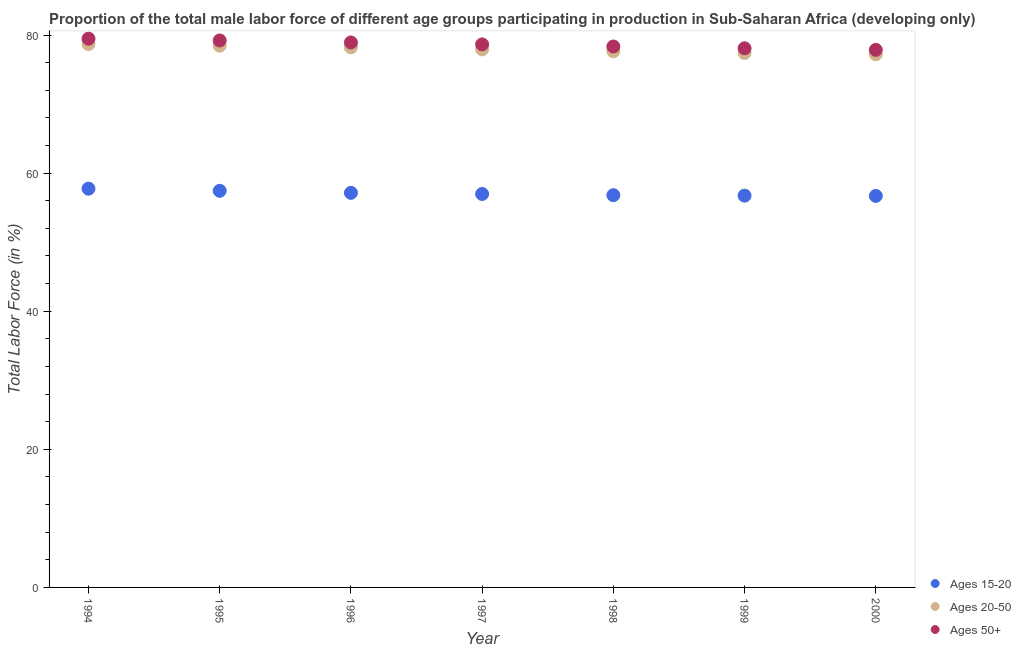How many different coloured dotlines are there?
Provide a short and direct response. 3. What is the percentage of male labor force within the age group 20-50 in 2000?
Ensure brevity in your answer.  77.21. Across all years, what is the maximum percentage of male labor force within the age group 20-50?
Ensure brevity in your answer.  78.69. Across all years, what is the minimum percentage of male labor force above age 50?
Provide a short and direct response. 77.85. In which year was the percentage of male labor force above age 50 minimum?
Provide a short and direct response. 2000. What is the total percentage of male labor force within the age group 15-20 in the graph?
Provide a short and direct response. 399.57. What is the difference between the percentage of male labor force above age 50 in 1995 and that in 1996?
Offer a very short reply. 0.29. What is the difference between the percentage of male labor force within the age group 15-20 in 1997 and the percentage of male labor force within the age group 20-50 in 1996?
Keep it short and to the point. -21.23. What is the average percentage of male labor force within the age group 15-20 per year?
Provide a succinct answer. 57.08. In the year 1995, what is the difference between the percentage of male labor force above age 50 and percentage of male labor force within the age group 20-50?
Provide a short and direct response. 0.76. What is the ratio of the percentage of male labor force above age 50 in 1997 to that in 2000?
Offer a very short reply. 1.01. Is the difference between the percentage of male labor force within the age group 20-50 in 1998 and 1999 greater than the difference between the percentage of male labor force above age 50 in 1998 and 1999?
Provide a succinct answer. No. What is the difference between the highest and the second highest percentage of male labor force above age 50?
Ensure brevity in your answer.  0.26. What is the difference between the highest and the lowest percentage of male labor force above age 50?
Your answer should be compact. 1.62. Is the percentage of male labor force above age 50 strictly greater than the percentage of male labor force within the age group 15-20 over the years?
Provide a succinct answer. Yes. What is the difference between two consecutive major ticks on the Y-axis?
Your answer should be compact. 20. Does the graph contain any zero values?
Provide a succinct answer. No. Does the graph contain grids?
Ensure brevity in your answer.  No. Where does the legend appear in the graph?
Provide a short and direct response. Bottom right. How many legend labels are there?
Make the answer very short. 3. What is the title of the graph?
Ensure brevity in your answer.  Proportion of the total male labor force of different age groups participating in production in Sub-Saharan Africa (developing only). What is the label or title of the X-axis?
Your answer should be very brief. Year. What is the Total Labor Force (in %) of Ages 15-20 in 1994?
Keep it short and to the point. 57.75. What is the Total Labor Force (in %) of Ages 20-50 in 1994?
Give a very brief answer. 78.69. What is the Total Labor Force (in %) in Ages 50+ in 1994?
Provide a succinct answer. 79.47. What is the Total Labor Force (in %) in Ages 15-20 in 1995?
Offer a very short reply. 57.44. What is the Total Labor Force (in %) in Ages 20-50 in 1995?
Make the answer very short. 78.45. What is the Total Labor Force (in %) of Ages 50+ in 1995?
Give a very brief answer. 79.22. What is the Total Labor Force (in %) in Ages 15-20 in 1996?
Your response must be concise. 57.15. What is the Total Labor Force (in %) in Ages 20-50 in 1996?
Offer a terse response. 78.21. What is the Total Labor Force (in %) of Ages 50+ in 1996?
Provide a short and direct response. 78.93. What is the Total Labor Force (in %) in Ages 15-20 in 1997?
Keep it short and to the point. 56.98. What is the Total Labor Force (in %) in Ages 20-50 in 1997?
Give a very brief answer. 77.92. What is the Total Labor Force (in %) of Ages 50+ in 1997?
Give a very brief answer. 78.65. What is the Total Labor Force (in %) of Ages 15-20 in 1998?
Provide a succinct answer. 56.81. What is the Total Labor Force (in %) in Ages 20-50 in 1998?
Your response must be concise. 77.65. What is the Total Labor Force (in %) of Ages 50+ in 1998?
Keep it short and to the point. 78.34. What is the Total Labor Force (in %) in Ages 15-20 in 1999?
Your response must be concise. 56.74. What is the Total Labor Force (in %) of Ages 20-50 in 1999?
Your answer should be very brief. 77.4. What is the Total Labor Force (in %) of Ages 50+ in 1999?
Offer a very short reply. 78.08. What is the Total Labor Force (in %) in Ages 15-20 in 2000?
Keep it short and to the point. 56.7. What is the Total Labor Force (in %) in Ages 20-50 in 2000?
Keep it short and to the point. 77.21. What is the Total Labor Force (in %) in Ages 50+ in 2000?
Ensure brevity in your answer.  77.85. Across all years, what is the maximum Total Labor Force (in %) in Ages 15-20?
Offer a terse response. 57.75. Across all years, what is the maximum Total Labor Force (in %) in Ages 20-50?
Ensure brevity in your answer.  78.69. Across all years, what is the maximum Total Labor Force (in %) of Ages 50+?
Your answer should be very brief. 79.47. Across all years, what is the minimum Total Labor Force (in %) in Ages 15-20?
Offer a very short reply. 56.7. Across all years, what is the minimum Total Labor Force (in %) in Ages 20-50?
Your answer should be very brief. 77.21. Across all years, what is the minimum Total Labor Force (in %) in Ages 50+?
Make the answer very short. 77.85. What is the total Total Labor Force (in %) of Ages 15-20 in the graph?
Give a very brief answer. 399.57. What is the total Total Labor Force (in %) of Ages 20-50 in the graph?
Offer a terse response. 545.55. What is the total Total Labor Force (in %) of Ages 50+ in the graph?
Provide a short and direct response. 550.54. What is the difference between the Total Labor Force (in %) in Ages 15-20 in 1994 and that in 1995?
Give a very brief answer. 0.31. What is the difference between the Total Labor Force (in %) of Ages 20-50 in 1994 and that in 1995?
Offer a terse response. 0.24. What is the difference between the Total Labor Force (in %) in Ages 50+ in 1994 and that in 1995?
Your answer should be very brief. 0.26. What is the difference between the Total Labor Force (in %) of Ages 15-20 in 1994 and that in 1996?
Offer a terse response. 0.6. What is the difference between the Total Labor Force (in %) of Ages 20-50 in 1994 and that in 1996?
Offer a very short reply. 0.48. What is the difference between the Total Labor Force (in %) of Ages 50+ in 1994 and that in 1996?
Provide a short and direct response. 0.54. What is the difference between the Total Labor Force (in %) in Ages 15-20 in 1994 and that in 1997?
Your answer should be very brief. 0.77. What is the difference between the Total Labor Force (in %) of Ages 20-50 in 1994 and that in 1997?
Offer a very short reply. 0.77. What is the difference between the Total Labor Force (in %) in Ages 50+ in 1994 and that in 1997?
Make the answer very short. 0.83. What is the difference between the Total Labor Force (in %) in Ages 15-20 in 1994 and that in 1998?
Your response must be concise. 0.94. What is the difference between the Total Labor Force (in %) in Ages 20-50 in 1994 and that in 1998?
Provide a short and direct response. 1.05. What is the difference between the Total Labor Force (in %) in Ages 50+ in 1994 and that in 1998?
Offer a terse response. 1.13. What is the difference between the Total Labor Force (in %) in Ages 15-20 in 1994 and that in 1999?
Offer a terse response. 1.01. What is the difference between the Total Labor Force (in %) in Ages 20-50 in 1994 and that in 1999?
Offer a very short reply. 1.29. What is the difference between the Total Labor Force (in %) of Ages 50+ in 1994 and that in 1999?
Give a very brief answer. 1.39. What is the difference between the Total Labor Force (in %) of Ages 15-20 in 1994 and that in 2000?
Keep it short and to the point. 1.05. What is the difference between the Total Labor Force (in %) in Ages 20-50 in 1994 and that in 2000?
Give a very brief answer. 1.48. What is the difference between the Total Labor Force (in %) in Ages 50+ in 1994 and that in 2000?
Give a very brief answer. 1.62. What is the difference between the Total Labor Force (in %) of Ages 15-20 in 1995 and that in 1996?
Keep it short and to the point. 0.29. What is the difference between the Total Labor Force (in %) in Ages 20-50 in 1995 and that in 1996?
Your answer should be very brief. 0.24. What is the difference between the Total Labor Force (in %) of Ages 50+ in 1995 and that in 1996?
Offer a very short reply. 0.29. What is the difference between the Total Labor Force (in %) in Ages 15-20 in 1995 and that in 1997?
Offer a terse response. 0.46. What is the difference between the Total Labor Force (in %) of Ages 20-50 in 1995 and that in 1997?
Your answer should be compact. 0.53. What is the difference between the Total Labor Force (in %) of Ages 50+ in 1995 and that in 1997?
Ensure brevity in your answer.  0.57. What is the difference between the Total Labor Force (in %) of Ages 15-20 in 1995 and that in 1998?
Provide a succinct answer. 0.63. What is the difference between the Total Labor Force (in %) of Ages 20-50 in 1995 and that in 1998?
Offer a very short reply. 0.81. What is the difference between the Total Labor Force (in %) of Ages 50+ in 1995 and that in 1998?
Offer a terse response. 0.88. What is the difference between the Total Labor Force (in %) in Ages 15-20 in 1995 and that in 1999?
Offer a very short reply. 0.7. What is the difference between the Total Labor Force (in %) of Ages 20-50 in 1995 and that in 1999?
Your response must be concise. 1.05. What is the difference between the Total Labor Force (in %) in Ages 50+ in 1995 and that in 1999?
Offer a terse response. 1.14. What is the difference between the Total Labor Force (in %) in Ages 15-20 in 1995 and that in 2000?
Offer a terse response. 0.74. What is the difference between the Total Labor Force (in %) of Ages 20-50 in 1995 and that in 2000?
Your response must be concise. 1.24. What is the difference between the Total Labor Force (in %) in Ages 50+ in 1995 and that in 2000?
Your answer should be very brief. 1.36. What is the difference between the Total Labor Force (in %) in Ages 15-20 in 1996 and that in 1997?
Your response must be concise. 0.17. What is the difference between the Total Labor Force (in %) in Ages 20-50 in 1996 and that in 1997?
Offer a terse response. 0.29. What is the difference between the Total Labor Force (in %) of Ages 50+ in 1996 and that in 1997?
Your answer should be very brief. 0.28. What is the difference between the Total Labor Force (in %) in Ages 15-20 in 1996 and that in 1998?
Give a very brief answer. 0.34. What is the difference between the Total Labor Force (in %) in Ages 20-50 in 1996 and that in 1998?
Make the answer very short. 0.57. What is the difference between the Total Labor Force (in %) in Ages 50+ in 1996 and that in 1998?
Provide a succinct answer. 0.59. What is the difference between the Total Labor Force (in %) of Ages 15-20 in 1996 and that in 1999?
Offer a terse response. 0.41. What is the difference between the Total Labor Force (in %) of Ages 20-50 in 1996 and that in 1999?
Give a very brief answer. 0.81. What is the difference between the Total Labor Force (in %) in Ages 50+ in 1996 and that in 1999?
Keep it short and to the point. 0.85. What is the difference between the Total Labor Force (in %) of Ages 15-20 in 1996 and that in 2000?
Your answer should be compact. 0.44. What is the difference between the Total Labor Force (in %) of Ages 20-50 in 1996 and that in 2000?
Your response must be concise. 1. What is the difference between the Total Labor Force (in %) in Ages 50+ in 1996 and that in 2000?
Offer a terse response. 1.07. What is the difference between the Total Labor Force (in %) of Ages 15-20 in 1997 and that in 1998?
Give a very brief answer. 0.17. What is the difference between the Total Labor Force (in %) of Ages 20-50 in 1997 and that in 1998?
Offer a terse response. 0.28. What is the difference between the Total Labor Force (in %) in Ages 50+ in 1997 and that in 1998?
Your response must be concise. 0.31. What is the difference between the Total Labor Force (in %) of Ages 15-20 in 1997 and that in 1999?
Your response must be concise. 0.24. What is the difference between the Total Labor Force (in %) in Ages 20-50 in 1997 and that in 1999?
Keep it short and to the point. 0.52. What is the difference between the Total Labor Force (in %) in Ages 50+ in 1997 and that in 1999?
Offer a very short reply. 0.57. What is the difference between the Total Labor Force (in %) in Ages 15-20 in 1997 and that in 2000?
Make the answer very short. 0.28. What is the difference between the Total Labor Force (in %) in Ages 20-50 in 1997 and that in 2000?
Offer a very short reply. 0.71. What is the difference between the Total Labor Force (in %) in Ages 50+ in 1997 and that in 2000?
Your response must be concise. 0.79. What is the difference between the Total Labor Force (in %) in Ages 15-20 in 1998 and that in 1999?
Provide a succinct answer. 0.07. What is the difference between the Total Labor Force (in %) in Ages 20-50 in 1998 and that in 1999?
Keep it short and to the point. 0.25. What is the difference between the Total Labor Force (in %) of Ages 50+ in 1998 and that in 1999?
Provide a succinct answer. 0.26. What is the difference between the Total Labor Force (in %) of Ages 15-20 in 1998 and that in 2000?
Make the answer very short. 0.1. What is the difference between the Total Labor Force (in %) of Ages 20-50 in 1998 and that in 2000?
Your answer should be very brief. 0.44. What is the difference between the Total Labor Force (in %) in Ages 50+ in 1998 and that in 2000?
Offer a terse response. 0.49. What is the difference between the Total Labor Force (in %) in Ages 15-20 in 1999 and that in 2000?
Ensure brevity in your answer.  0.04. What is the difference between the Total Labor Force (in %) in Ages 20-50 in 1999 and that in 2000?
Make the answer very short. 0.19. What is the difference between the Total Labor Force (in %) of Ages 50+ in 1999 and that in 2000?
Offer a terse response. 0.23. What is the difference between the Total Labor Force (in %) of Ages 15-20 in 1994 and the Total Labor Force (in %) of Ages 20-50 in 1995?
Your answer should be compact. -20.7. What is the difference between the Total Labor Force (in %) in Ages 15-20 in 1994 and the Total Labor Force (in %) in Ages 50+ in 1995?
Your answer should be compact. -21.47. What is the difference between the Total Labor Force (in %) in Ages 20-50 in 1994 and the Total Labor Force (in %) in Ages 50+ in 1995?
Provide a short and direct response. -0.52. What is the difference between the Total Labor Force (in %) in Ages 15-20 in 1994 and the Total Labor Force (in %) in Ages 20-50 in 1996?
Provide a succinct answer. -20.46. What is the difference between the Total Labor Force (in %) of Ages 15-20 in 1994 and the Total Labor Force (in %) of Ages 50+ in 1996?
Make the answer very short. -21.18. What is the difference between the Total Labor Force (in %) in Ages 20-50 in 1994 and the Total Labor Force (in %) in Ages 50+ in 1996?
Your response must be concise. -0.23. What is the difference between the Total Labor Force (in %) in Ages 15-20 in 1994 and the Total Labor Force (in %) in Ages 20-50 in 1997?
Offer a terse response. -20.17. What is the difference between the Total Labor Force (in %) in Ages 15-20 in 1994 and the Total Labor Force (in %) in Ages 50+ in 1997?
Keep it short and to the point. -20.9. What is the difference between the Total Labor Force (in %) in Ages 20-50 in 1994 and the Total Labor Force (in %) in Ages 50+ in 1997?
Your answer should be very brief. 0.05. What is the difference between the Total Labor Force (in %) of Ages 15-20 in 1994 and the Total Labor Force (in %) of Ages 20-50 in 1998?
Provide a succinct answer. -19.9. What is the difference between the Total Labor Force (in %) in Ages 15-20 in 1994 and the Total Labor Force (in %) in Ages 50+ in 1998?
Your answer should be compact. -20.59. What is the difference between the Total Labor Force (in %) in Ages 20-50 in 1994 and the Total Labor Force (in %) in Ages 50+ in 1998?
Ensure brevity in your answer.  0.35. What is the difference between the Total Labor Force (in %) in Ages 15-20 in 1994 and the Total Labor Force (in %) in Ages 20-50 in 1999?
Provide a short and direct response. -19.65. What is the difference between the Total Labor Force (in %) in Ages 15-20 in 1994 and the Total Labor Force (in %) in Ages 50+ in 1999?
Offer a terse response. -20.33. What is the difference between the Total Labor Force (in %) of Ages 20-50 in 1994 and the Total Labor Force (in %) of Ages 50+ in 1999?
Offer a terse response. 0.61. What is the difference between the Total Labor Force (in %) in Ages 15-20 in 1994 and the Total Labor Force (in %) in Ages 20-50 in 2000?
Your response must be concise. -19.46. What is the difference between the Total Labor Force (in %) of Ages 15-20 in 1994 and the Total Labor Force (in %) of Ages 50+ in 2000?
Your answer should be compact. -20.1. What is the difference between the Total Labor Force (in %) of Ages 20-50 in 1994 and the Total Labor Force (in %) of Ages 50+ in 2000?
Provide a succinct answer. 0.84. What is the difference between the Total Labor Force (in %) of Ages 15-20 in 1995 and the Total Labor Force (in %) of Ages 20-50 in 1996?
Ensure brevity in your answer.  -20.77. What is the difference between the Total Labor Force (in %) in Ages 15-20 in 1995 and the Total Labor Force (in %) in Ages 50+ in 1996?
Provide a short and direct response. -21.49. What is the difference between the Total Labor Force (in %) of Ages 20-50 in 1995 and the Total Labor Force (in %) of Ages 50+ in 1996?
Make the answer very short. -0.47. What is the difference between the Total Labor Force (in %) in Ages 15-20 in 1995 and the Total Labor Force (in %) in Ages 20-50 in 1997?
Your answer should be compact. -20.48. What is the difference between the Total Labor Force (in %) of Ages 15-20 in 1995 and the Total Labor Force (in %) of Ages 50+ in 1997?
Provide a succinct answer. -21.2. What is the difference between the Total Labor Force (in %) in Ages 20-50 in 1995 and the Total Labor Force (in %) in Ages 50+ in 1997?
Offer a terse response. -0.19. What is the difference between the Total Labor Force (in %) of Ages 15-20 in 1995 and the Total Labor Force (in %) of Ages 20-50 in 1998?
Your answer should be very brief. -20.21. What is the difference between the Total Labor Force (in %) of Ages 15-20 in 1995 and the Total Labor Force (in %) of Ages 50+ in 1998?
Keep it short and to the point. -20.9. What is the difference between the Total Labor Force (in %) of Ages 20-50 in 1995 and the Total Labor Force (in %) of Ages 50+ in 1998?
Ensure brevity in your answer.  0.11. What is the difference between the Total Labor Force (in %) in Ages 15-20 in 1995 and the Total Labor Force (in %) in Ages 20-50 in 1999?
Provide a succinct answer. -19.96. What is the difference between the Total Labor Force (in %) in Ages 15-20 in 1995 and the Total Labor Force (in %) in Ages 50+ in 1999?
Make the answer very short. -20.64. What is the difference between the Total Labor Force (in %) of Ages 20-50 in 1995 and the Total Labor Force (in %) of Ages 50+ in 1999?
Give a very brief answer. 0.37. What is the difference between the Total Labor Force (in %) of Ages 15-20 in 1995 and the Total Labor Force (in %) of Ages 20-50 in 2000?
Your response must be concise. -19.77. What is the difference between the Total Labor Force (in %) in Ages 15-20 in 1995 and the Total Labor Force (in %) in Ages 50+ in 2000?
Provide a short and direct response. -20.41. What is the difference between the Total Labor Force (in %) of Ages 20-50 in 1995 and the Total Labor Force (in %) of Ages 50+ in 2000?
Make the answer very short. 0.6. What is the difference between the Total Labor Force (in %) of Ages 15-20 in 1996 and the Total Labor Force (in %) of Ages 20-50 in 1997?
Your answer should be compact. -20.78. What is the difference between the Total Labor Force (in %) of Ages 15-20 in 1996 and the Total Labor Force (in %) of Ages 50+ in 1997?
Your answer should be very brief. -21.5. What is the difference between the Total Labor Force (in %) in Ages 20-50 in 1996 and the Total Labor Force (in %) in Ages 50+ in 1997?
Your answer should be compact. -0.43. What is the difference between the Total Labor Force (in %) in Ages 15-20 in 1996 and the Total Labor Force (in %) in Ages 20-50 in 1998?
Give a very brief answer. -20.5. What is the difference between the Total Labor Force (in %) of Ages 15-20 in 1996 and the Total Labor Force (in %) of Ages 50+ in 1998?
Ensure brevity in your answer.  -21.19. What is the difference between the Total Labor Force (in %) of Ages 20-50 in 1996 and the Total Labor Force (in %) of Ages 50+ in 1998?
Your answer should be compact. -0.13. What is the difference between the Total Labor Force (in %) of Ages 15-20 in 1996 and the Total Labor Force (in %) of Ages 20-50 in 1999?
Make the answer very short. -20.25. What is the difference between the Total Labor Force (in %) in Ages 15-20 in 1996 and the Total Labor Force (in %) in Ages 50+ in 1999?
Offer a very short reply. -20.93. What is the difference between the Total Labor Force (in %) in Ages 20-50 in 1996 and the Total Labor Force (in %) in Ages 50+ in 1999?
Provide a succinct answer. 0.13. What is the difference between the Total Labor Force (in %) of Ages 15-20 in 1996 and the Total Labor Force (in %) of Ages 20-50 in 2000?
Ensure brevity in your answer.  -20.06. What is the difference between the Total Labor Force (in %) of Ages 15-20 in 1996 and the Total Labor Force (in %) of Ages 50+ in 2000?
Provide a short and direct response. -20.71. What is the difference between the Total Labor Force (in %) of Ages 20-50 in 1996 and the Total Labor Force (in %) of Ages 50+ in 2000?
Make the answer very short. 0.36. What is the difference between the Total Labor Force (in %) in Ages 15-20 in 1997 and the Total Labor Force (in %) in Ages 20-50 in 1998?
Make the answer very short. -20.67. What is the difference between the Total Labor Force (in %) in Ages 15-20 in 1997 and the Total Labor Force (in %) in Ages 50+ in 1998?
Ensure brevity in your answer.  -21.36. What is the difference between the Total Labor Force (in %) of Ages 20-50 in 1997 and the Total Labor Force (in %) of Ages 50+ in 1998?
Give a very brief answer. -0.42. What is the difference between the Total Labor Force (in %) in Ages 15-20 in 1997 and the Total Labor Force (in %) in Ages 20-50 in 1999?
Your response must be concise. -20.42. What is the difference between the Total Labor Force (in %) in Ages 15-20 in 1997 and the Total Labor Force (in %) in Ages 50+ in 1999?
Provide a succinct answer. -21.1. What is the difference between the Total Labor Force (in %) of Ages 20-50 in 1997 and the Total Labor Force (in %) of Ages 50+ in 1999?
Your answer should be very brief. -0.16. What is the difference between the Total Labor Force (in %) of Ages 15-20 in 1997 and the Total Labor Force (in %) of Ages 20-50 in 2000?
Ensure brevity in your answer.  -20.23. What is the difference between the Total Labor Force (in %) in Ages 15-20 in 1997 and the Total Labor Force (in %) in Ages 50+ in 2000?
Your answer should be very brief. -20.87. What is the difference between the Total Labor Force (in %) in Ages 20-50 in 1997 and the Total Labor Force (in %) in Ages 50+ in 2000?
Your answer should be compact. 0.07. What is the difference between the Total Labor Force (in %) of Ages 15-20 in 1998 and the Total Labor Force (in %) of Ages 20-50 in 1999?
Make the answer very short. -20.59. What is the difference between the Total Labor Force (in %) in Ages 15-20 in 1998 and the Total Labor Force (in %) in Ages 50+ in 1999?
Offer a very short reply. -21.27. What is the difference between the Total Labor Force (in %) in Ages 20-50 in 1998 and the Total Labor Force (in %) in Ages 50+ in 1999?
Your answer should be very brief. -0.43. What is the difference between the Total Labor Force (in %) of Ages 15-20 in 1998 and the Total Labor Force (in %) of Ages 20-50 in 2000?
Keep it short and to the point. -20.4. What is the difference between the Total Labor Force (in %) in Ages 15-20 in 1998 and the Total Labor Force (in %) in Ages 50+ in 2000?
Make the answer very short. -21.05. What is the difference between the Total Labor Force (in %) in Ages 20-50 in 1998 and the Total Labor Force (in %) in Ages 50+ in 2000?
Provide a short and direct response. -0.21. What is the difference between the Total Labor Force (in %) of Ages 15-20 in 1999 and the Total Labor Force (in %) of Ages 20-50 in 2000?
Make the answer very short. -20.47. What is the difference between the Total Labor Force (in %) in Ages 15-20 in 1999 and the Total Labor Force (in %) in Ages 50+ in 2000?
Provide a succinct answer. -21.11. What is the difference between the Total Labor Force (in %) of Ages 20-50 in 1999 and the Total Labor Force (in %) of Ages 50+ in 2000?
Your answer should be very brief. -0.45. What is the average Total Labor Force (in %) in Ages 15-20 per year?
Provide a succinct answer. 57.08. What is the average Total Labor Force (in %) of Ages 20-50 per year?
Offer a terse response. 77.94. What is the average Total Labor Force (in %) of Ages 50+ per year?
Provide a short and direct response. 78.65. In the year 1994, what is the difference between the Total Labor Force (in %) of Ages 15-20 and Total Labor Force (in %) of Ages 20-50?
Offer a very short reply. -20.94. In the year 1994, what is the difference between the Total Labor Force (in %) in Ages 15-20 and Total Labor Force (in %) in Ages 50+?
Ensure brevity in your answer.  -21.72. In the year 1994, what is the difference between the Total Labor Force (in %) in Ages 20-50 and Total Labor Force (in %) in Ages 50+?
Make the answer very short. -0.78. In the year 1995, what is the difference between the Total Labor Force (in %) of Ages 15-20 and Total Labor Force (in %) of Ages 20-50?
Your answer should be compact. -21.01. In the year 1995, what is the difference between the Total Labor Force (in %) of Ages 15-20 and Total Labor Force (in %) of Ages 50+?
Your answer should be very brief. -21.77. In the year 1995, what is the difference between the Total Labor Force (in %) in Ages 20-50 and Total Labor Force (in %) in Ages 50+?
Make the answer very short. -0.76. In the year 1996, what is the difference between the Total Labor Force (in %) of Ages 15-20 and Total Labor Force (in %) of Ages 20-50?
Your answer should be compact. -21.07. In the year 1996, what is the difference between the Total Labor Force (in %) of Ages 15-20 and Total Labor Force (in %) of Ages 50+?
Provide a succinct answer. -21.78. In the year 1996, what is the difference between the Total Labor Force (in %) in Ages 20-50 and Total Labor Force (in %) in Ages 50+?
Give a very brief answer. -0.71. In the year 1997, what is the difference between the Total Labor Force (in %) in Ages 15-20 and Total Labor Force (in %) in Ages 20-50?
Keep it short and to the point. -20.94. In the year 1997, what is the difference between the Total Labor Force (in %) of Ages 15-20 and Total Labor Force (in %) of Ages 50+?
Your answer should be compact. -21.67. In the year 1997, what is the difference between the Total Labor Force (in %) in Ages 20-50 and Total Labor Force (in %) in Ages 50+?
Offer a terse response. -0.72. In the year 1998, what is the difference between the Total Labor Force (in %) in Ages 15-20 and Total Labor Force (in %) in Ages 20-50?
Offer a terse response. -20.84. In the year 1998, what is the difference between the Total Labor Force (in %) in Ages 15-20 and Total Labor Force (in %) in Ages 50+?
Make the answer very short. -21.53. In the year 1998, what is the difference between the Total Labor Force (in %) in Ages 20-50 and Total Labor Force (in %) in Ages 50+?
Offer a terse response. -0.69. In the year 1999, what is the difference between the Total Labor Force (in %) of Ages 15-20 and Total Labor Force (in %) of Ages 20-50?
Your response must be concise. -20.66. In the year 1999, what is the difference between the Total Labor Force (in %) of Ages 15-20 and Total Labor Force (in %) of Ages 50+?
Offer a terse response. -21.34. In the year 1999, what is the difference between the Total Labor Force (in %) in Ages 20-50 and Total Labor Force (in %) in Ages 50+?
Offer a terse response. -0.68. In the year 2000, what is the difference between the Total Labor Force (in %) in Ages 15-20 and Total Labor Force (in %) in Ages 20-50?
Give a very brief answer. -20.51. In the year 2000, what is the difference between the Total Labor Force (in %) of Ages 15-20 and Total Labor Force (in %) of Ages 50+?
Keep it short and to the point. -21.15. In the year 2000, what is the difference between the Total Labor Force (in %) of Ages 20-50 and Total Labor Force (in %) of Ages 50+?
Offer a terse response. -0.64. What is the ratio of the Total Labor Force (in %) in Ages 15-20 in 1994 to that in 1995?
Offer a terse response. 1.01. What is the ratio of the Total Labor Force (in %) in Ages 20-50 in 1994 to that in 1995?
Offer a terse response. 1. What is the ratio of the Total Labor Force (in %) in Ages 15-20 in 1994 to that in 1996?
Provide a short and direct response. 1.01. What is the ratio of the Total Labor Force (in %) in Ages 50+ in 1994 to that in 1996?
Give a very brief answer. 1.01. What is the ratio of the Total Labor Force (in %) of Ages 15-20 in 1994 to that in 1997?
Provide a short and direct response. 1.01. What is the ratio of the Total Labor Force (in %) of Ages 20-50 in 1994 to that in 1997?
Keep it short and to the point. 1.01. What is the ratio of the Total Labor Force (in %) in Ages 50+ in 1994 to that in 1997?
Keep it short and to the point. 1.01. What is the ratio of the Total Labor Force (in %) of Ages 15-20 in 1994 to that in 1998?
Provide a short and direct response. 1.02. What is the ratio of the Total Labor Force (in %) of Ages 20-50 in 1994 to that in 1998?
Your answer should be very brief. 1.01. What is the ratio of the Total Labor Force (in %) of Ages 50+ in 1994 to that in 1998?
Provide a succinct answer. 1.01. What is the ratio of the Total Labor Force (in %) in Ages 15-20 in 1994 to that in 1999?
Ensure brevity in your answer.  1.02. What is the ratio of the Total Labor Force (in %) of Ages 20-50 in 1994 to that in 1999?
Your answer should be very brief. 1.02. What is the ratio of the Total Labor Force (in %) of Ages 50+ in 1994 to that in 1999?
Offer a terse response. 1.02. What is the ratio of the Total Labor Force (in %) in Ages 15-20 in 1994 to that in 2000?
Provide a short and direct response. 1.02. What is the ratio of the Total Labor Force (in %) in Ages 20-50 in 1994 to that in 2000?
Your answer should be compact. 1.02. What is the ratio of the Total Labor Force (in %) of Ages 50+ in 1994 to that in 2000?
Provide a short and direct response. 1.02. What is the ratio of the Total Labor Force (in %) in Ages 15-20 in 1995 to that in 1996?
Your answer should be compact. 1.01. What is the ratio of the Total Labor Force (in %) of Ages 20-50 in 1995 to that in 1996?
Provide a succinct answer. 1. What is the ratio of the Total Labor Force (in %) of Ages 50+ in 1995 to that in 1996?
Provide a short and direct response. 1. What is the ratio of the Total Labor Force (in %) of Ages 20-50 in 1995 to that in 1997?
Give a very brief answer. 1.01. What is the ratio of the Total Labor Force (in %) of Ages 50+ in 1995 to that in 1997?
Provide a short and direct response. 1.01. What is the ratio of the Total Labor Force (in %) in Ages 15-20 in 1995 to that in 1998?
Provide a succinct answer. 1.01. What is the ratio of the Total Labor Force (in %) of Ages 20-50 in 1995 to that in 1998?
Provide a succinct answer. 1.01. What is the ratio of the Total Labor Force (in %) of Ages 50+ in 1995 to that in 1998?
Keep it short and to the point. 1.01. What is the ratio of the Total Labor Force (in %) in Ages 15-20 in 1995 to that in 1999?
Make the answer very short. 1.01. What is the ratio of the Total Labor Force (in %) of Ages 20-50 in 1995 to that in 1999?
Offer a very short reply. 1.01. What is the ratio of the Total Labor Force (in %) of Ages 50+ in 1995 to that in 1999?
Your response must be concise. 1.01. What is the ratio of the Total Labor Force (in %) in Ages 20-50 in 1995 to that in 2000?
Make the answer very short. 1.02. What is the ratio of the Total Labor Force (in %) in Ages 50+ in 1995 to that in 2000?
Your response must be concise. 1.02. What is the ratio of the Total Labor Force (in %) of Ages 50+ in 1996 to that in 1997?
Your answer should be compact. 1. What is the ratio of the Total Labor Force (in %) in Ages 15-20 in 1996 to that in 1998?
Keep it short and to the point. 1.01. What is the ratio of the Total Labor Force (in %) of Ages 20-50 in 1996 to that in 1998?
Provide a short and direct response. 1.01. What is the ratio of the Total Labor Force (in %) of Ages 50+ in 1996 to that in 1998?
Give a very brief answer. 1.01. What is the ratio of the Total Labor Force (in %) of Ages 15-20 in 1996 to that in 1999?
Offer a terse response. 1.01. What is the ratio of the Total Labor Force (in %) of Ages 20-50 in 1996 to that in 1999?
Your answer should be compact. 1.01. What is the ratio of the Total Labor Force (in %) in Ages 50+ in 1996 to that in 1999?
Keep it short and to the point. 1.01. What is the ratio of the Total Labor Force (in %) of Ages 20-50 in 1996 to that in 2000?
Make the answer very short. 1.01. What is the ratio of the Total Labor Force (in %) of Ages 50+ in 1996 to that in 2000?
Offer a terse response. 1.01. What is the ratio of the Total Labor Force (in %) of Ages 15-20 in 1997 to that in 1998?
Offer a terse response. 1. What is the ratio of the Total Labor Force (in %) in Ages 50+ in 1997 to that in 1998?
Give a very brief answer. 1. What is the ratio of the Total Labor Force (in %) of Ages 20-50 in 1997 to that in 1999?
Keep it short and to the point. 1.01. What is the ratio of the Total Labor Force (in %) of Ages 15-20 in 1997 to that in 2000?
Your answer should be compact. 1. What is the ratio of the Total Labor Force (in %) of Ages 20-50 in 1997 to that in 2000?
Offer a very short reply. 1.01. What is the ratio of the Total Labor Force (in %) of Ages 50+ in 1997 to that in 2000?
Provide a short and direct response. 1.01. What is the ratio of the Total Labor Force (in %) in Ages 15-20 in 1998 to that in 1999?
Offer a terse response. 1. What is the ratio of the Total Labor Force (in %) in Ages 50+ in 1998 to that in 2000?
Provide a short and direct response. 1.01. What is the ratio of the Total Labor Force (in %) in Ages 15-20 in 1999 to that in 2000?
Provide a short and direct response. 1. What is the ratio of the Total Labor Force (in %) of Ages 50+ in 1999 to that in 2000?
Your answer should be very brief. 1. What is the difference between the highest and the second highest Total Labor Force (in %) of Ages 15-20?
Your answer should be very brief. 0.31. What is the difference between the highest and the second highest Total Labor Force (in %) in Ages 20-50?
Provide a short and direct response. 0.24. What is the difference between the highest and the second highest Total Labor Force (in %) of Ages 50+?
Your response must be concise. 0.26. What is the difference between the highest and the lowest Total Labor Force (in %) in Ages 15-20?
Provide a short and direct response. 1.05. What is the difference between the highest and the lowest Total Labor Force (in %) in Ages 20-50?
Keep it short and to the point. 1.48. What is the difference between the highest and the lowest Total Labor Force (in %) of Ages 50+?
Provide a succinct answer. 1.62. 